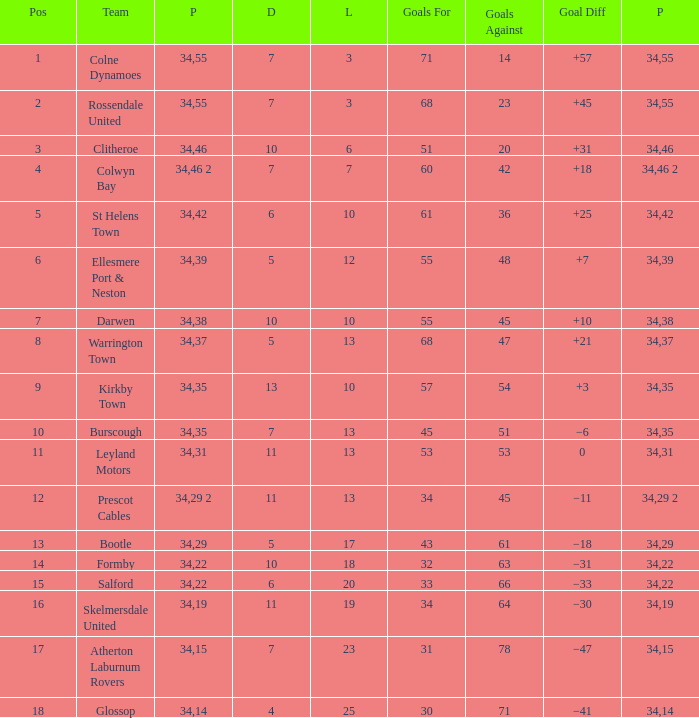Which Position has 47 Goals Against, and a Played larger than 34? None. 